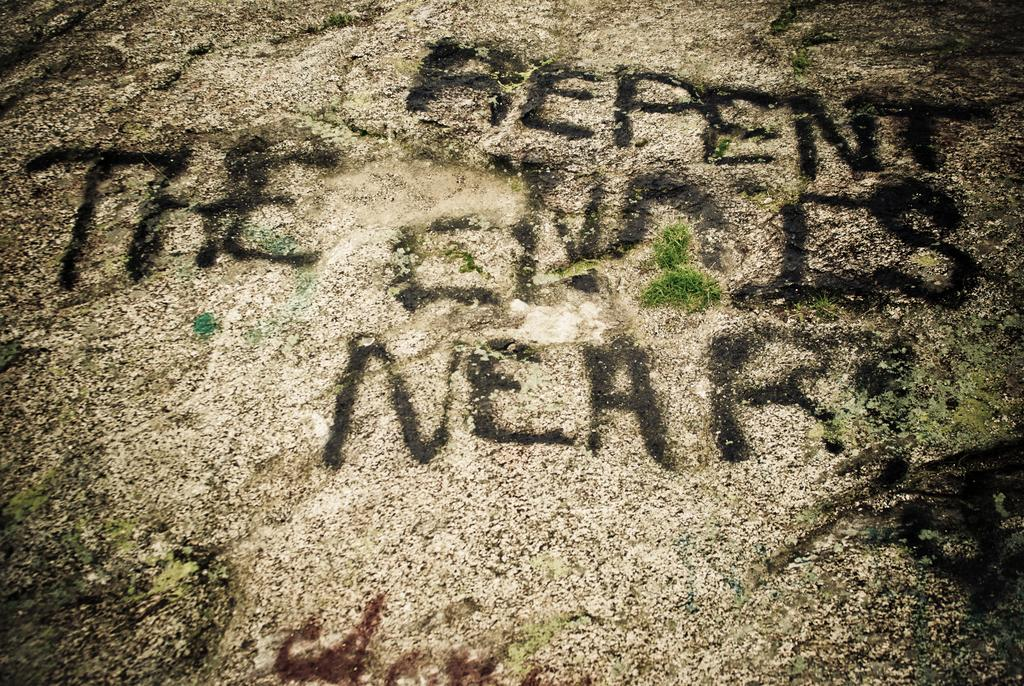What is the focus of the image? The image is zoomed in. What can be seen in the foreground of the image? There is ground visible in the foreground of the image. What is written on the ground in the image? Text is written on the ground. How long does it take for the company to kick the ball in the image? There is no company or ball present in the image; it only features ground with text written on it. 